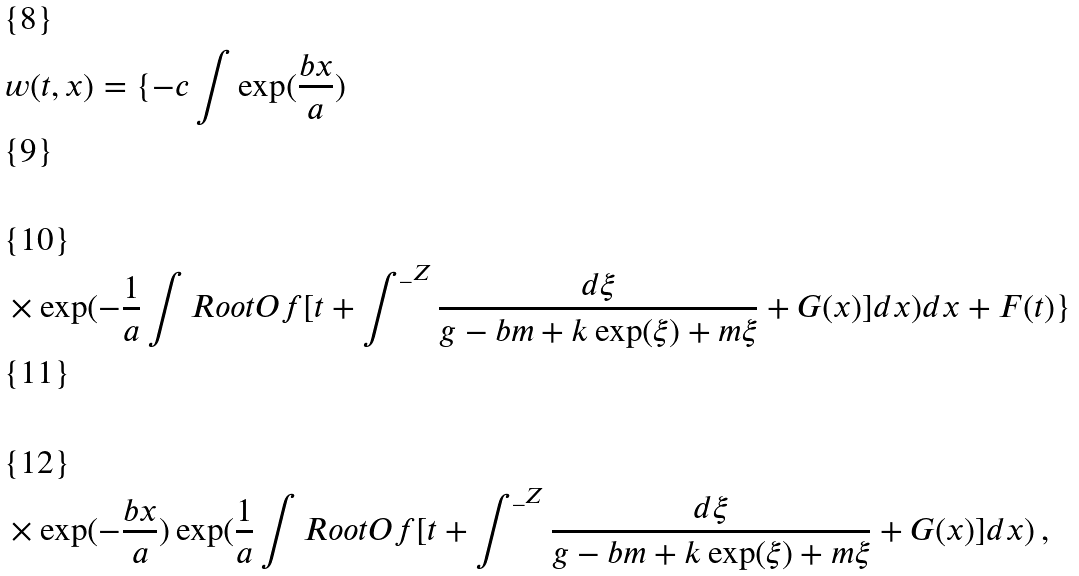<formula> <loc_0><loc_0><loc_500><loc_500>& w ( t , x ) = \{ - c \int \exp ( \frac { b x } { a } ) \\ \\ & \times \exp ( - \frac { 1 } { a } \int R o o t O f [ t + \int ^ { \_ Z } \frac { d \xi } { g - b m + k \exp ( \xi ) + m \xi } + G ( x ) ] d x ) d x + F ( t ) \} \\ \\ & \times \exp ( - \frac { b x } { a } ) \exp ( \frac { 1 } { a } \int R o o t O f [ t + \int ^ { \_ Z } \frac { d \xi } { g - b m + k \exp ( \xi ) + m \xi } + G ( x ) ] d x ) \, ,</formula> 